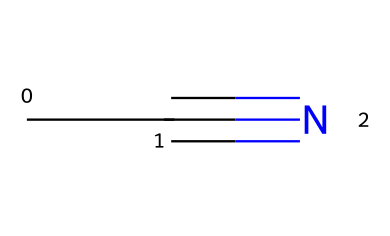What is the molecular formula of acetonitrile? The SMILES representation CC#N indicates that there are two carbon atoms (C) and one nitrogen atom (N), which collectively form the molecular formula C2H3N.
Answer: C2H3N How many carbon atoms are present in this structure? The SMILES notation CC#N clearly indicates that there are two 'C' characters at the beginning, representing two carbon atoms in acetonitrile.
Answer: 2 What type of bond connects the carbon and nitrogen in this compound? The presence of the '#' symbol in the SMILES notation CC#N signifies a triple bond between the carbon and nitrogen, which is characteristic of nitriles.
Answer: triple bond What is the hybridization of the carbon atom connected to the nitrogen in acetonitrile? In acetonitrile, the carbon atom directly bonded to nitrogen is sp hybridized due to forming a triple bond with nitrogen (and a single bond with another carbon).
Answer: sp How many total atoms are in acetonitrile? The molecular formula C2H3N indicates a total of 6 atoms: 2 carbon (C), 3 hydrogen (H), and 1 nitrogen (N).
Answer: 6 What functional group is represented by the structure CC#N? The triple bond present in the SMILES notation identifies this compound as a nitrile, which is a characteristic functional group of nitriles.
Answer: nitrile What is the main use of acetonitrile in industry? Acetonitrile is primarily used as a solvent due to its high polarity and ability to dissolve a wide range of substances, making it useful in various industrial applications, including 3D printing.
Answer: solvent 